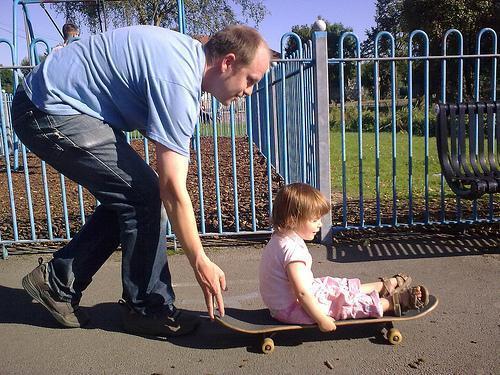How many people are present?
Give a very brief answer. 2. 